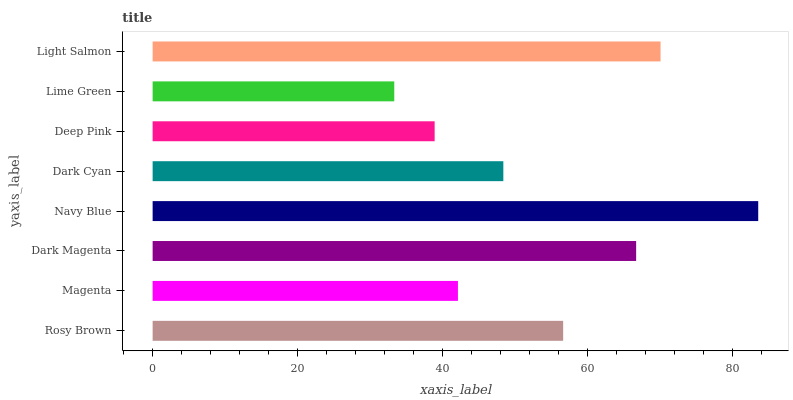Is Lime Green the minimum?
Answer yes or no. Yes. Is Navy Blue the maximum?
Answer yes or no. Yes. Is Magenta the minimum?
Answer yes or no. No. Is Magenta the maximum?
Answer yes or no. No. Is Rosy Brown greater than Magenta?
Answer yes or no. Yes. Is Magenta less than Rosy Brown?
Answer yes or no. Yes. Is Magenta greater than Rosy Brown?
Answer yes or no. No. Is Rosy Brown less than Magenta?
Answer yes or no. No. Is Rosy Brown the high median?
Answer yes or no. Yes. Is Dark Cyan the low median?
Answer yes or no. Yes. Is Magenta the high median?
Answer yes or no. No. Is Light Salmon the low median?
Answer yes or no. No. 